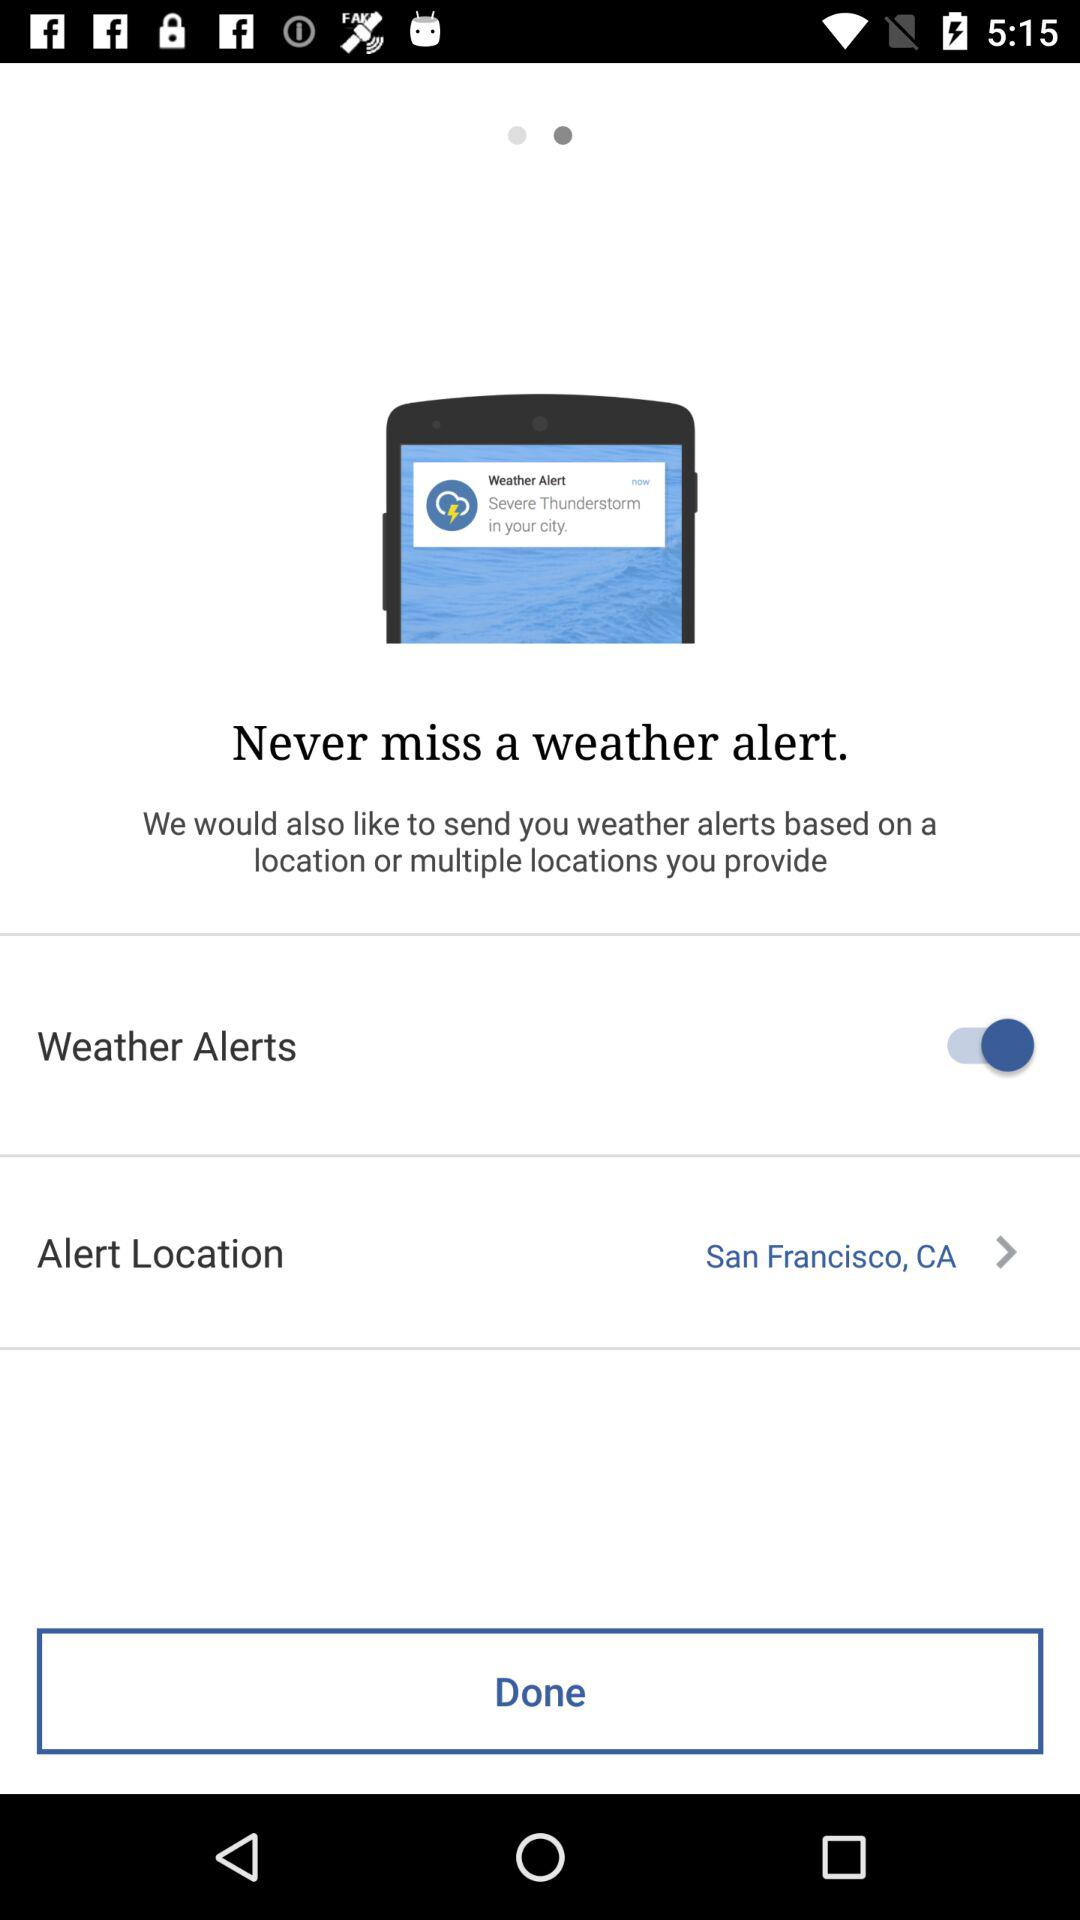What's the status of "Weather Alerts"? The status is "on". 